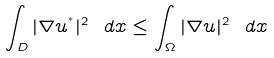<formula> <loc_0><loc_0><loc_500><loc_500>\int _ { D } | \nabla u ^ { ^ { * } } | ^ { 2 } \ d x \leq \int _ { \Omega } | \nabla u | ^ { 2 } \ d x</formula> 